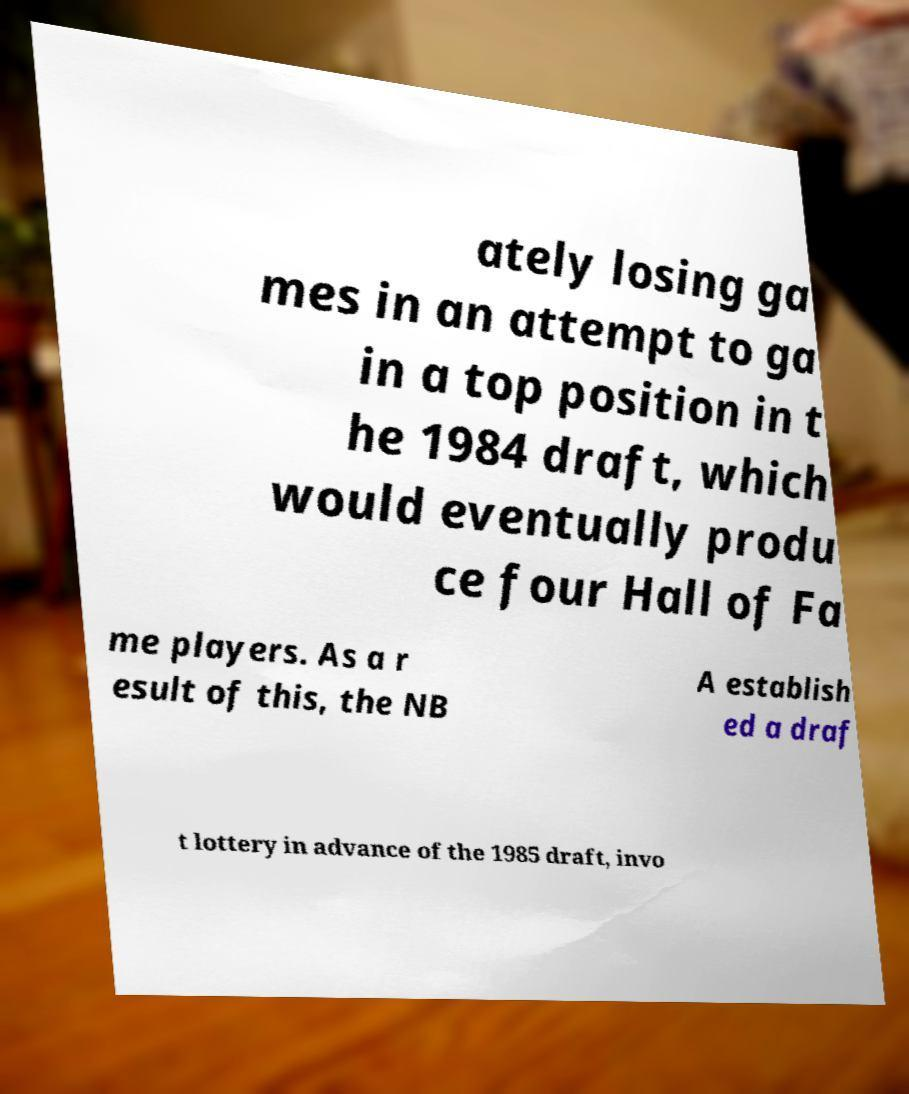Can you accurately transcribe the text from the provided image for me? ately losing ga mes in an attempt to ga in a top position in t he 1984 draft, which would eventually produ ce four Hall of Fa me players. As a r esult of this, the NB A establish ed a draf t lottery in advance of the 1985 draft, invo 